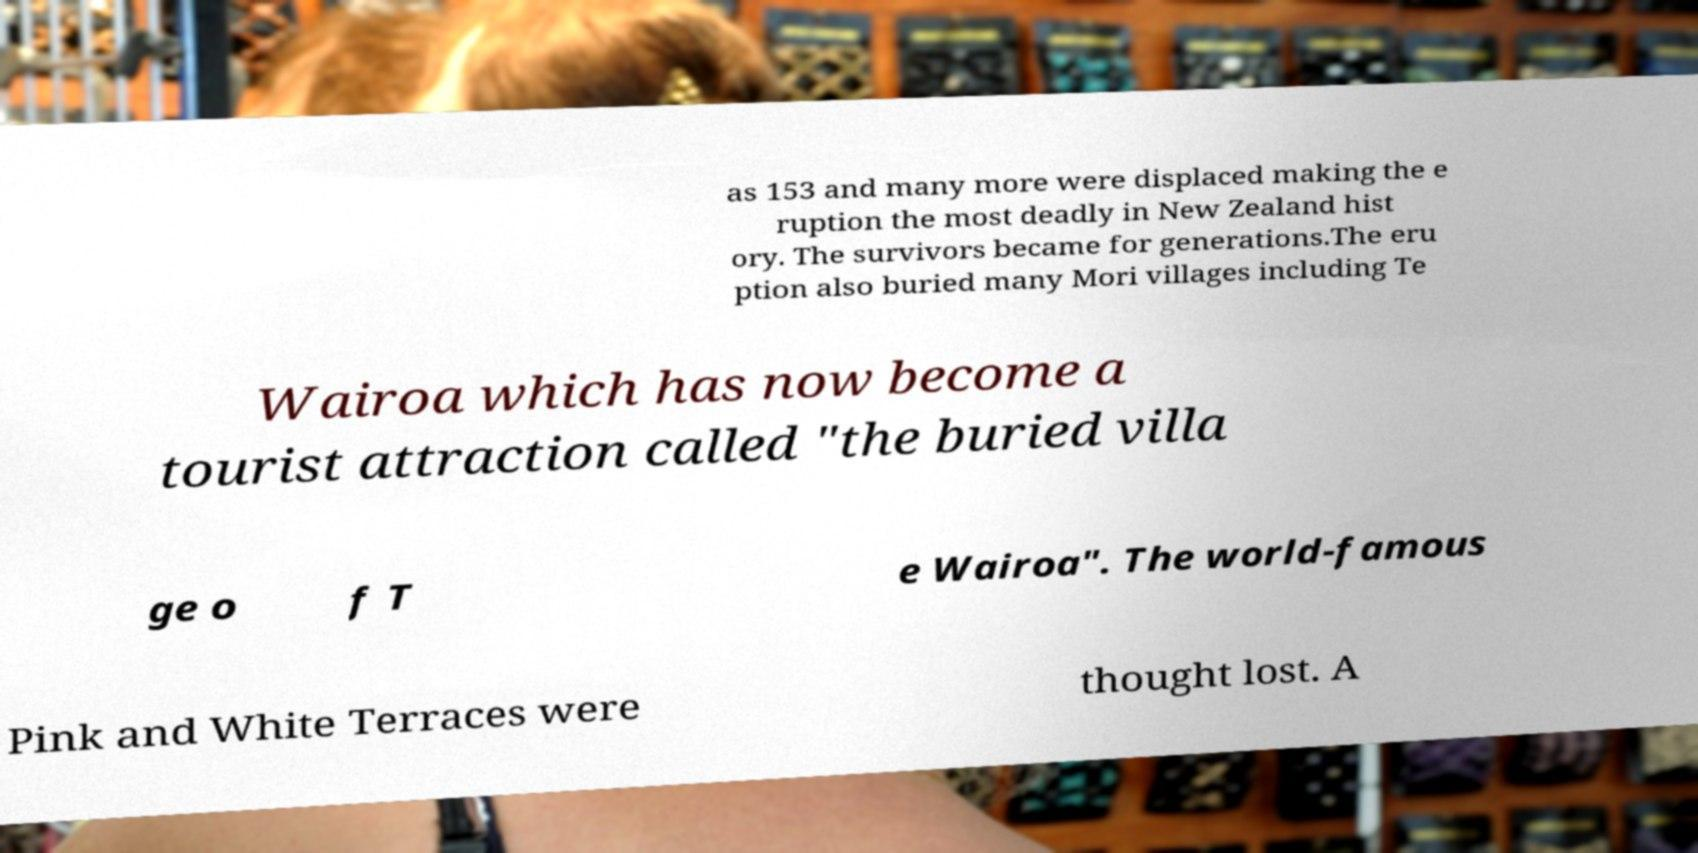What messages or text are displayed in this image? I need them in a readable, typed format. as 153 and many more were displaced making the e ruption the most deadly in New Zealand hist ory. The survivors became for generations.The eru ption also buried many Mori villages including Te Wairoa which has now become a tourist attraction called "the buried villa ge o f T e Wairoa". The world-famous Pink and White Terraces were thought lost. A 